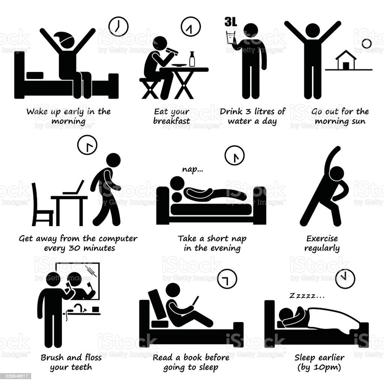What could be the reasoning behind the specific bedtime of 10 pm as suggested in this image? The suggested bedtime of 10 pm in the image is likely based on circadian rhythm research indicating that consistent early sleep times help improve overall sleep quality and can boost morning alertness. This habit aligns with the philosophy of achieving optimal health by ensuring adequate rest. 